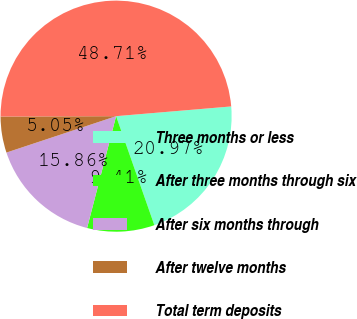<chart> <loc_0><loc_0><loc_500><loc_500><pie_chart><fcel>Three months or less<fcel>After three months through six<fcel>After six months through<fcel>After twelve months<fcel>Total term deposits<nl><fcel>20.97%<fcel>9.41%<fcel>15.86%<fcel>5.05%<fcel>48.71%<nl></chart> 